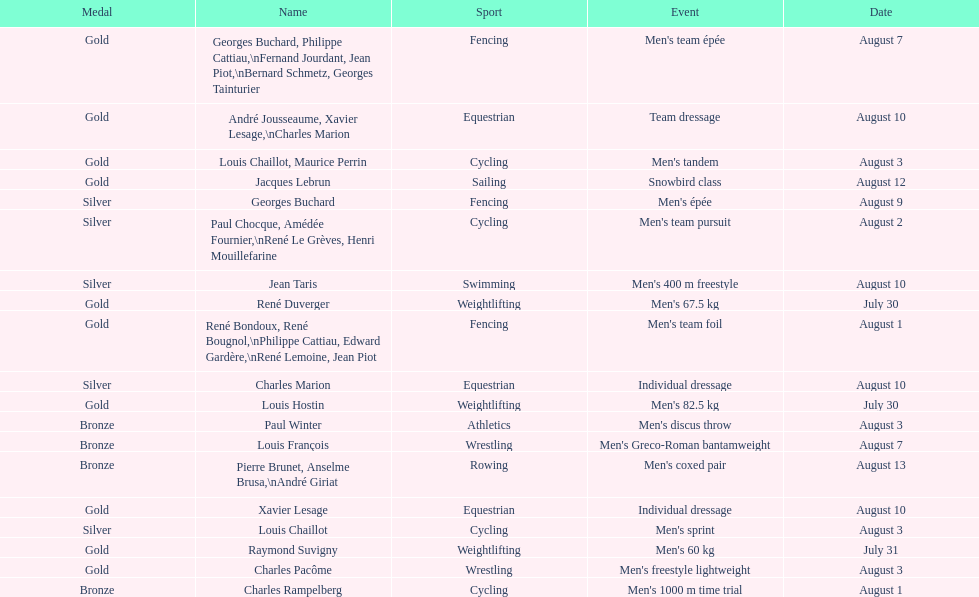Was there more gold medals won than silver? Yes. 